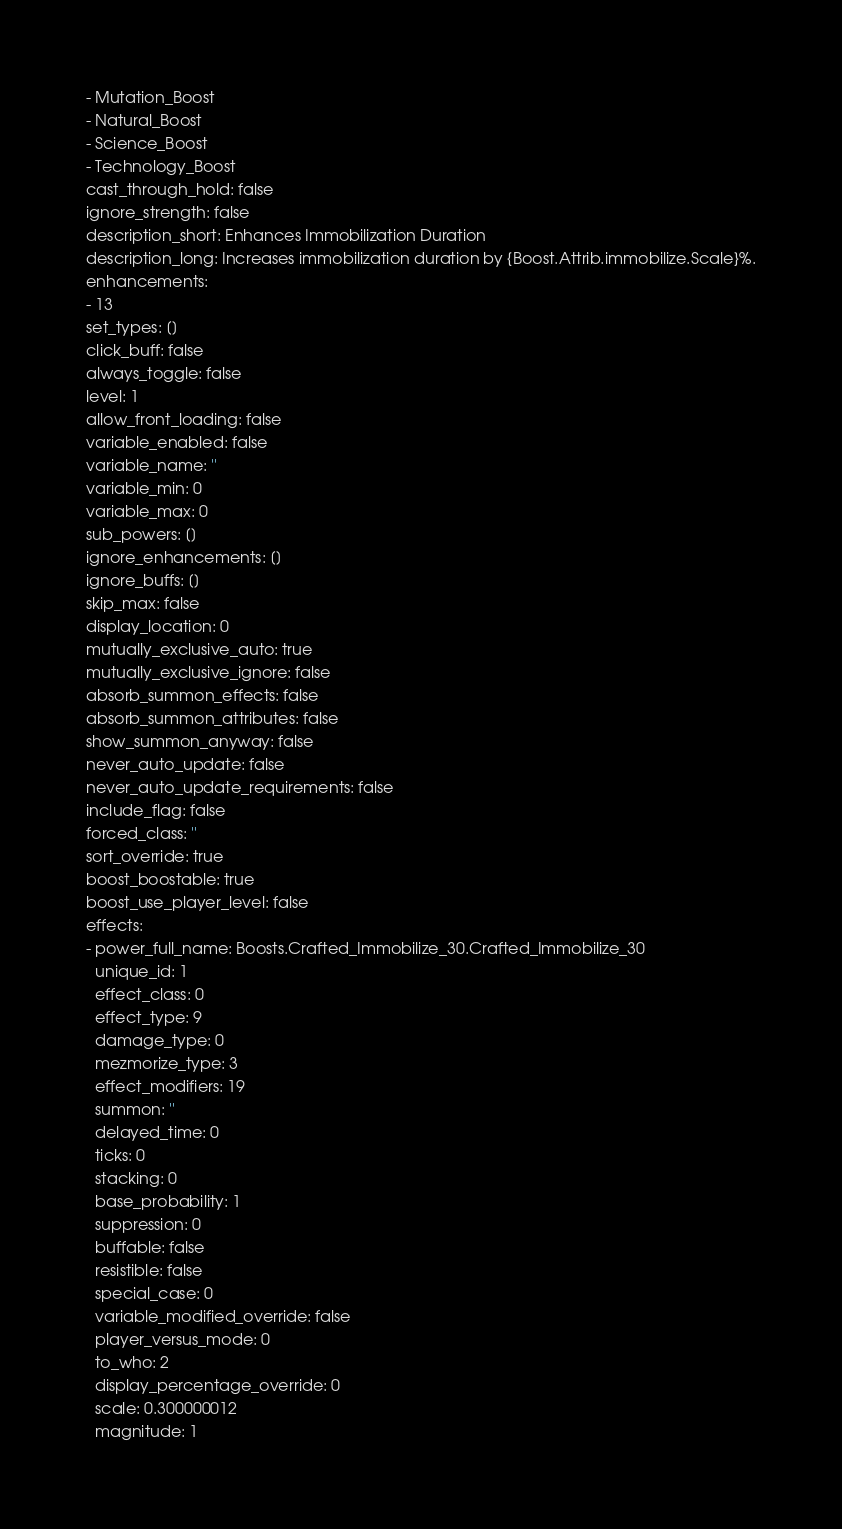<code> <loc_0><loc_0><loc_500><loc_500><_YAML_>- Mutation_Boost
- Natural_Boost
- Science_Boost
- Technology_Boost
cast_through_hold: false
ignore_strength: false
description_short: Enhances Immobilization Duration
description_long: Increases immobilization duration by {Boost.Attrib.immobilize.Scale}%.
enhancements:
- 13
set_types: []
click_buff: false
always_toggle: false
level: 1
allow_front_loading: false
variable_enabled: false
variable_name: ''
variable_min: 0
variable_max: 0
sub_powers: []
ignore_enhancements: []
ignore_buffs: []
skip_max: false
display_location: 0
mutually_exclusive_auto: true
mutually_exclusive_ignore: false
absorb_summon_effects: false
absorb_summon_attributes: false
show_summon_anyway: false
never_auto_update: false
never_auto_update_requirements: false
include_flag: false
forced_class: ''
sort_override: true
boost_boostable: true
boost_use_player_level: false
effects:
- power_full_name: Boosts.Crafted_Immobilize_30.Crafted_Immobilize_30
  unique_id: 1
  effect_class: 0
  effect_type: 9
  damage_type: 0
  mezmorize_type: 3
  effect_modifiers: 19
  summon: ''
  delayed_time: 0
  ticks: 0
  stacking: 0
  base_probability: 1
  suppression: 0
  buffable: false
  resistible: false
  special_case: 0
  variable_modified_override: false
  player_versus_mode: 0
  to_who: 2
  display_percentage_override: 0
  scale: 0.300000012
  magnitude: 1</code> 